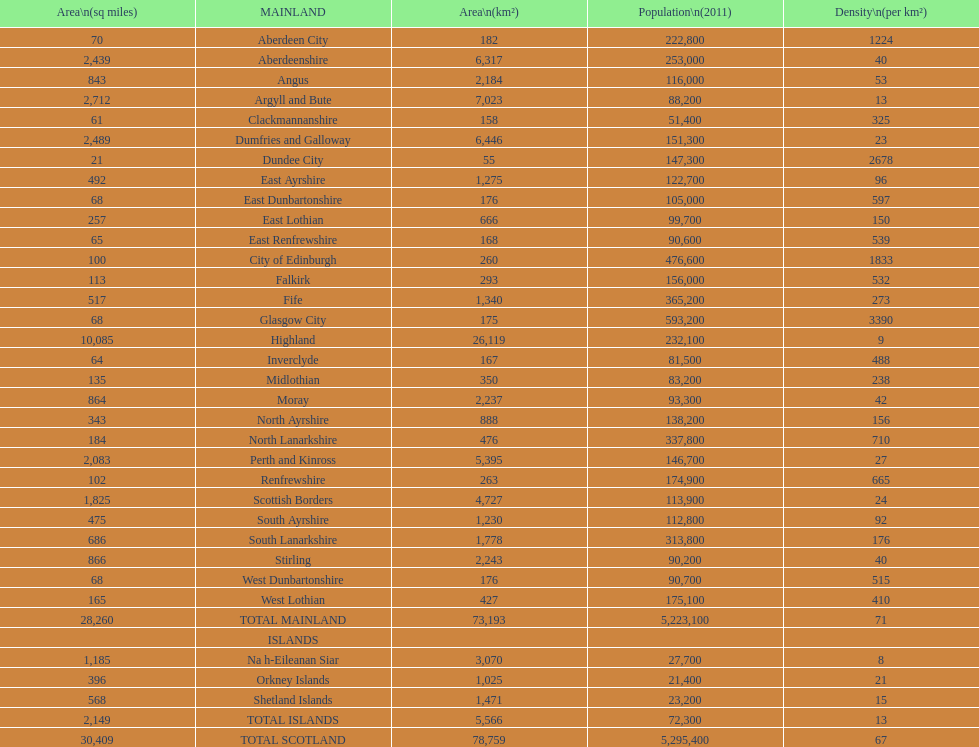Which mainland has the least population? Clackmannanshire. 